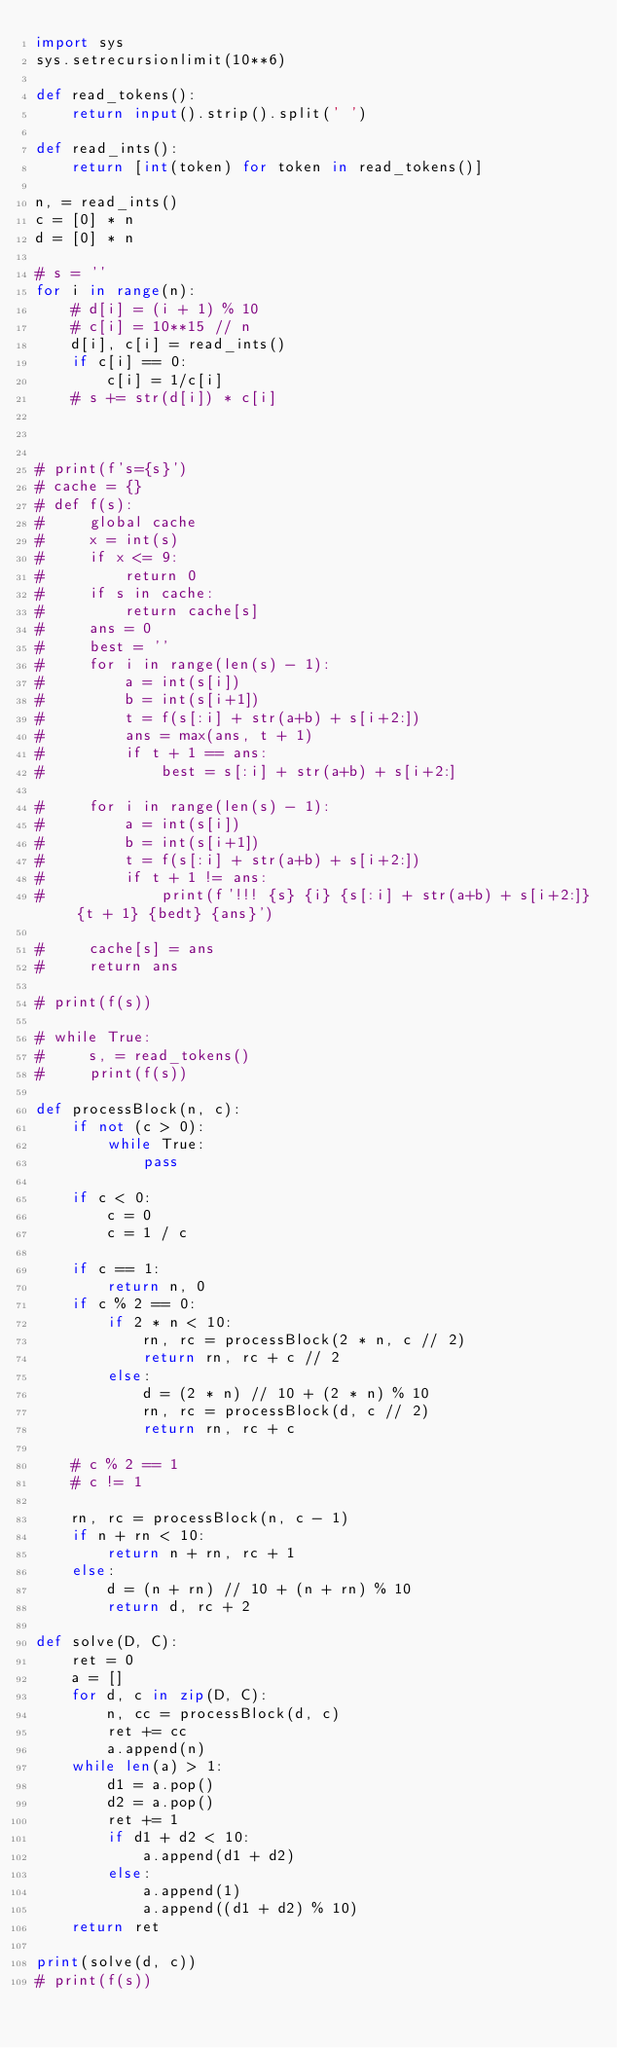Convert code to text. <code><loc_0><loc_0><loc_500><loc_500><_Python_>import sys
sys.setrecursionlimit(10**6)

def read_tokens():
    return input().strip().split(' ')

def read_ints():
    return [int(token) for token in read_tokens()]

n, = read_ints()
c = [0] * n
d = [0] * n

# s = ''
for i in range(n):
    # d[i] = (i + 1) % 10
    # c[i] = 10**15 // n
    d[i], c[i] = read_ints()
    if c[i] == 0:
        c[i] = 1/c[i]
    # s += str(d[i]) * c[i]



# print(f's={s}')
# cache = {}
# def f(s):
#     global cache
#     x = int(s)
#     if x <= 9:
#         return 0
#     if s in cache:
#         return cache[s]
#     ans = 0
#     best = ''
#     for i in range(len(s) - 1):
#         a = int(s[i])
#         b = int(s[i+1])
#         t = f(s[:i] + str(a+b) + s[i+2:])
#         ans = max(ans, t + 1)
#         if t + 1 == ans:
#             best = s[:i] + str(a+b) + s[i+2:]

#     for i in range(len(s) - 1):
#         a = int(s[i])
#         b = int(s[i+1])
#         t = f(s[:i] + str(a+b) + s[i+2:])
#         if t + 1 != ans:
#             print(f'!!! {s} {i} {s[:i] + str(a+b) + s[i+2:]} {t + 1} {bedt} {ans}')

#     cache[s] = ans
#     return ans

# print(f(s))

# while True:
#     s, = read_tokens()
#     print(f(s))

def processBlock(n, c):
    if not (c > 0):
        while True:
            pass

    if c < 0:
        c = 0
        c = 1 / c
        
    if c == 1:
        return n, 0
    if c % 2 == 0:
        if 2 * n < 10:
            rn, rc = processBlock(2 * n, c // 2)
            return rn, rc + c // 2
        else:
            d = (2 * n) // 10 + (2 * n) % 10
            rn, rc = processBlock(d, c // 2)
            return rn, rc + c

    # c % 2 == 1
    # c != 1

    rn, rc = processBlock(n, c - 1)
    if n + rn < 10:
        return n + rn, rc + 1
    else:
        d = (n + rn) // 10 + (n + rn) % 10
        return d, rc + 2

def solve(D, C):
    ret = 0
    a = []
    for d, c in zip(D, C):
        n, cc = processBlock(d, c)
        ret += cc
        a.append(n)
    while len(a) > 1:
        d1 = a.pop()
        d2 = a.pop()
        ret += 1
        if d1 + d2 < 10:
            a.append(d1 + d2)
        else:
            a.append(1)
            a.append((d1 + d2) % 10)
    return ret

print(solve(d, c))
# print(f(s))</code> 